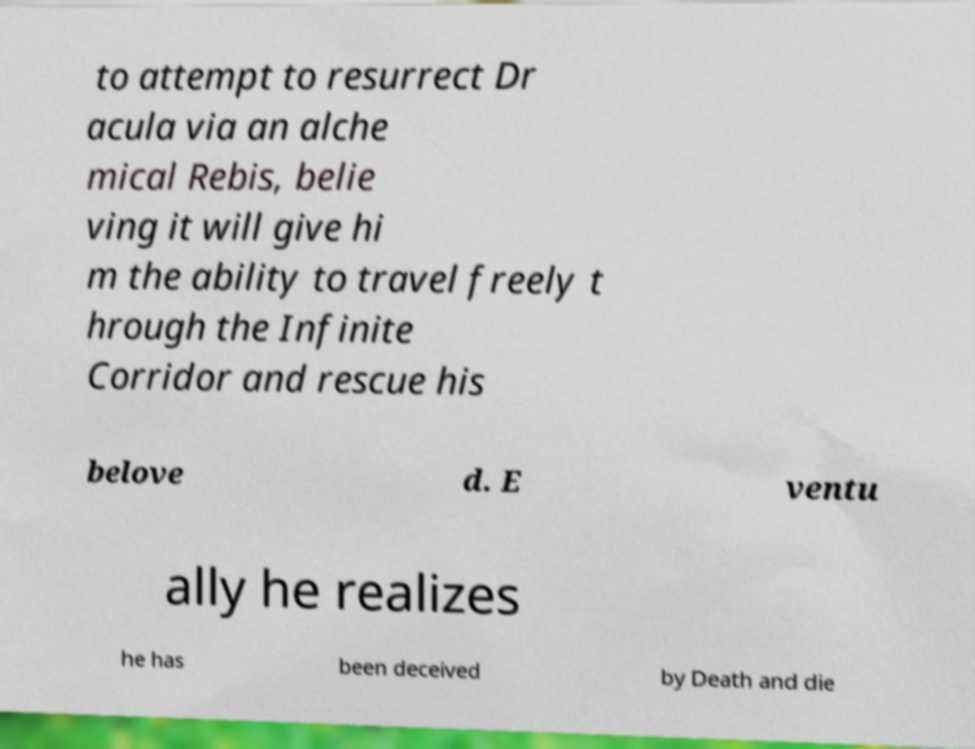Please read and relay the text visible in this image. What does it say? to attempt to resurrect Dr acula via an alche mical Rebis, belie ving it will give hi m the ability to travel freely t hrough the Infinite Corridor and rescue his belove d. E ventu ally he realizes he has been deceived by Death and die 